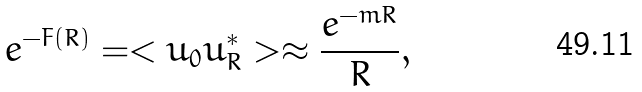<formula> <loc_0><loc_0><loc_500><loc_500>e ^ { - F ( R ) } = < u _ { 0 } u _ { R } ^ { \ast } > \approx \frac { e ^ { - m R } } { R } ,</formula> 